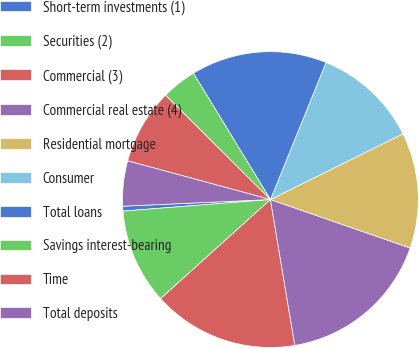<chart> <loc_0><loc_0><loc_500><loc_500><pie_chart><fcel>Short-term investments (1)<fcel>Securities (2)<fcel>Commercial (3)<fcel>Commercial real estate (4)<fcel>Residential mortgage<fcel>Consumer<fcel>Total loans<fcel>Savings interest-bearing<fcel>Time<fcel>Total deposits<nl><fcel>0.53%<fcel>10.44%<fcel>15.95%<fcel>17.05%<fcel>12.64%<fcel>11.54%<fcel>14.85%<fcel>3.83%<fcel>8.24%<fcel>4.93%<nl></chart> 